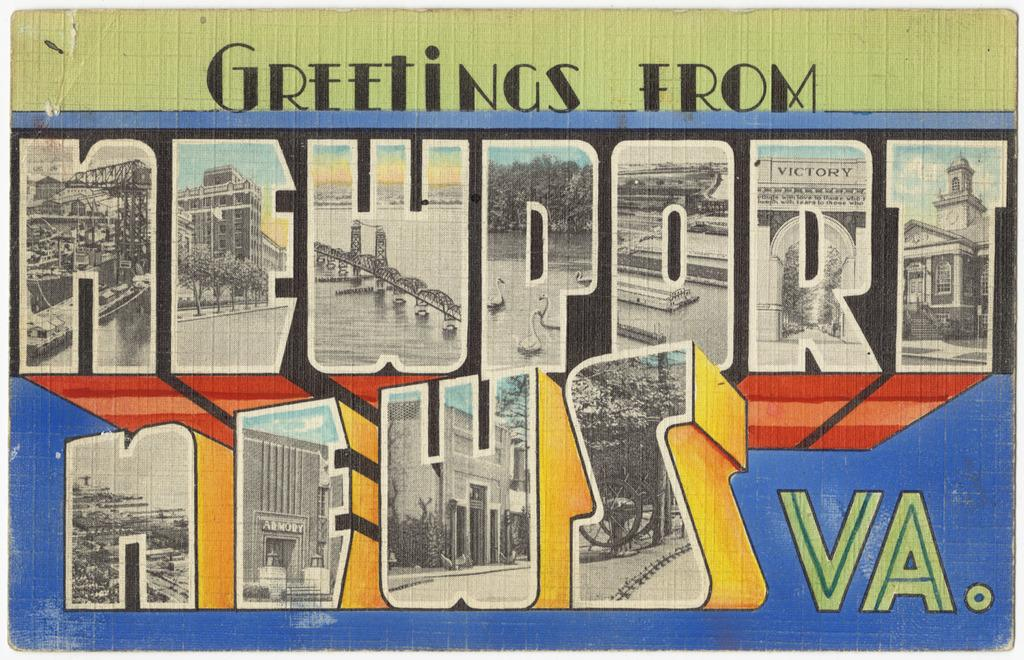<image>
Offer a succinct explanation of the picture presented. a colored postcard with greetings from newport news VA on it 